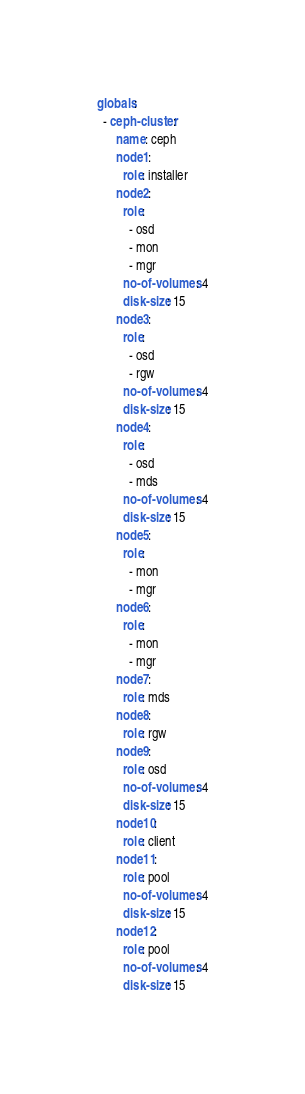<code> <loc_0><loc_0><loc_500><loc_500><_YAML_>globals:
  - ceph-cluster:
      name: ceph
      node1:
        role: installer
      node2:
        role:
          - osd
          - mon
          - mgr
        no-of-volumes: 4
        disk-size: 15
      node3:
        role:
          - osd
          - rgw
        no-of-volumes: 4
        disk-size: 15
      node4:
        role:
          - osd
          - mds
        no-of-volumes: 4
        disk-size: 15
      node5:
        role:
          - mon
          - mgr
      node6:
        role:
          - mon
          - mgr
      node7:
        role: mds
      node8:
        role: rgw
      node9:
        role: osd
        no-of-volumes: 4
        disk-size: 15
      node10:
        role: client
      node11:
        role: pool
        no-of-volumes: 4
        disk-size: 15
      node12:
        role: pool
        no-of-volumes: 4
        disk-size: 15
</code> 